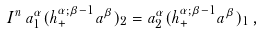<formula> <loc_0><loc_0><loc_500><loc_500>I ^ { n } \, a _ { 1 } ^ { \alpha } ( h _ { + } ^ { \alpha ; \beta - 1 } a ^ { \beta } ) _ { 2 } = a _ { 2 } ^ { \alpha } ( h _ { + } ^ { \alpha ; \beta - 1 } a ^ { \beta } ) _ { 1 } \, ,</formula> 